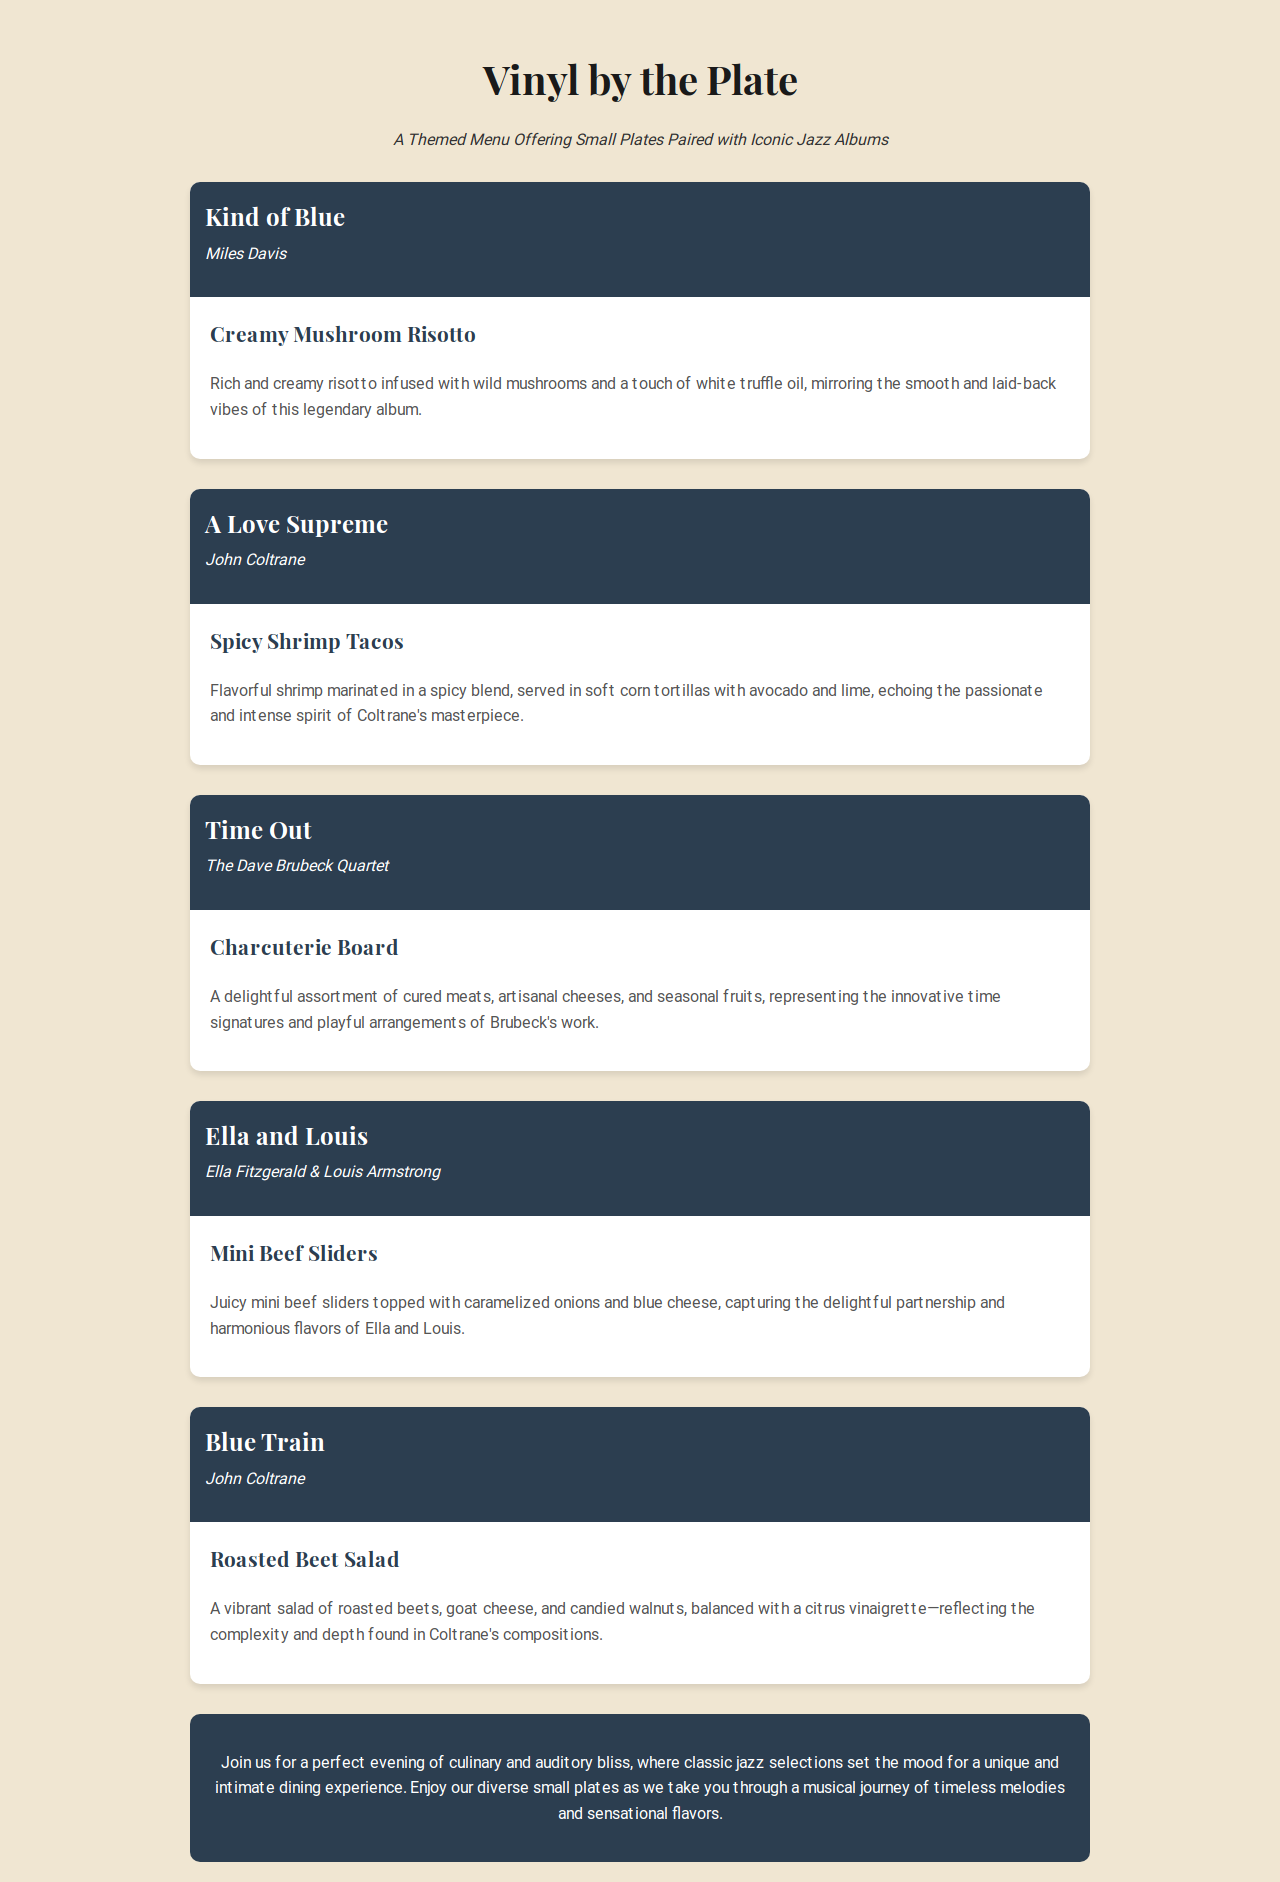What is the title of the first album? The title of the first album mentioned in the document is "Kind of Blue."
Answer: Kind of Blue Who is the artist of the album "A Love Supreme"? The document specifies that "A Love Supreme" is by John Coltrane.
Answer: John Coltrane What is the name of the small plate paired with "Time Out"? According to the menu, the small plate paired with "Time Out" is the "Charcuterie Board."
Answer: Charcuterie Board How many small plates are featured in the menu? The document lists a total of five small plates offered.
Answer: Five Which small plate reflects the complexity of John Coltrane's compositions? The menu indicates that the "Roasted Beet Salad" reflects the complexity of Coltrane's compositions.
Answer: Roasted Beet Salad What type of experience does the restaurant offer? The document states that the restaurant offers a "unique and intimate dining experience."
Answer: Unique and intimate dining experience What ingredient is used in the Creamy Mushroom Risotto? The description mentions that the risotto is infused with wild mushrooms.
Answer: Wild mushrooms What musical era does the menu celebrate? The theme of the menu revolves around classic jazz selections.
Answer: Classic jazz selections What is the color scheme of the backgrounds in the menu? The background color of the document is a light beige with darker sections for album information and dining experience.
Answer: Light beige and dark sections 